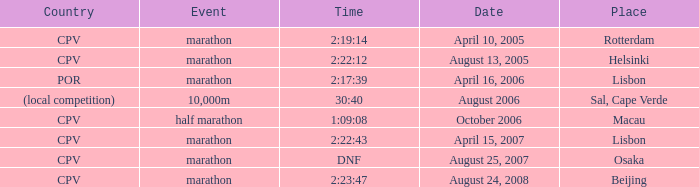Where does the half marathon event take place? Macau. 